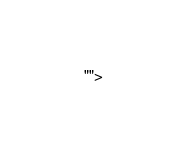Convert code to text. <code><loc_0><loc_0><loc_500><loc_500><_HTML_>    ""></code> 